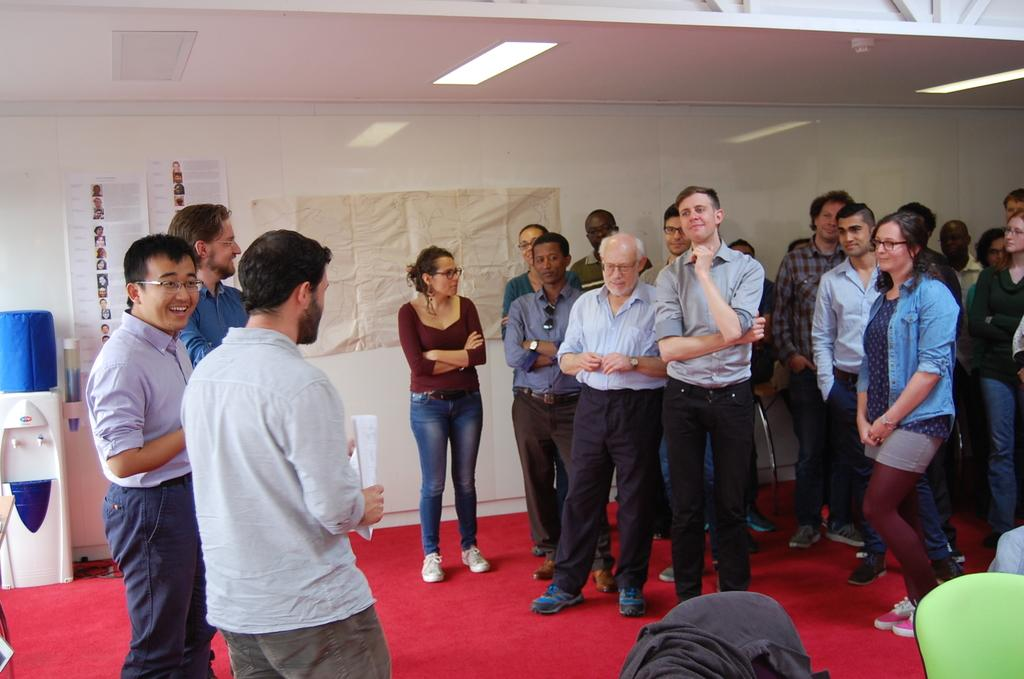How many people are in the image? There is a group of people in the image. What color is the floor in the image? The floor is red in color. What can be seen on the wall in the image? There is a wall with posters in the image. What appliance is visible in the image? There is a water filter in the image. What type of test is being conducted by the minister in the image? There is no minister or test present in the image. 